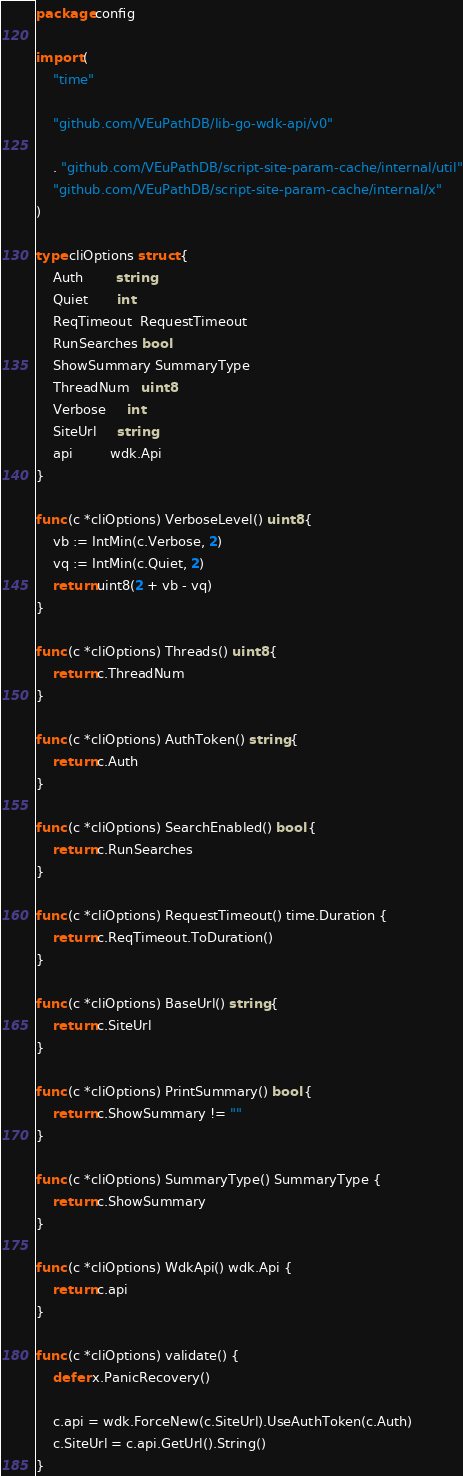<code> <loc_0><loc_0><loc_500><loc_500><_Go_>package config

import (
	"time"

	"github.com/VEuPathDB/lib-go-wdk-api/v0"

	. "github.com/VEuPathDB/script-site-param-cache/internal/util"
	"github.com/VEuPathDB/script-site-param-cache/internal/x"
)

type cliOptions struct {
	Auth        string
	Quiet       int
	ReqTimeout  RequestTimeout
	RunSearches bool
	ShowSummary SummaryType
	ThreadNum   uint8
	Verbose     int
	SiteUrl     string
	api         wdk.Api
}

func (c *cliOptions) VerboseLevel() uint8 {
	vb := IntMin(c.Verbose, 2)
	vq := IntMin(c.Quiet, 2)
	return uint8(2 + vb - vq)
}

func (c *cliOptions) Threads() uint8 {
	return c.ThreadNum
}

func (c *cliOptions) AuthToken() string {
	return c.Auth
}

func (c *cliOptions) SearchEnabled() bool {
	return c.RunSearches
}

func (c *cliOptions) RequestTimeout() time.Duration {
	return c.ReqTimeout.ToDuration()
}

func (c *cliOptions) BaseUrl() string {
	return c.SiteUrl
}

func (c *cliOptions) PrintSummary() bool {
	return c.ShowSummary != ""
}

func (c *cliOptions) SummaryType() SummaryType {
	return c.ShowSummary
}

func (c *cliOptions) WdkApi() wdk.Api {
	return c.api
}

func (c *cliOptions) validate() {
	defer x.PanicRecovery()

	c.api = wdk.ForceNew(c.SiteUrl).UseAuthToken(c.Auth)
	c.SiteUrl = c.api.GetUrl().String()
}
</code> 